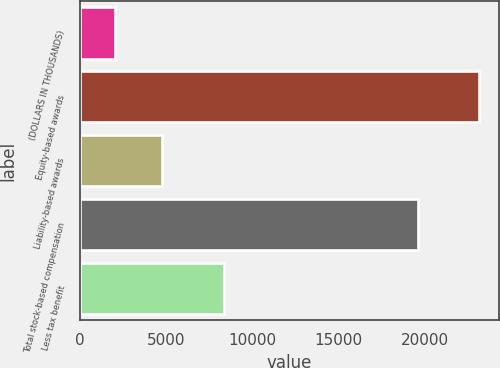Convert chart. <chart><loc_0><loc_0><loc_500><loc_500><bar_chart><fcel>(DOLLARS IN THOUSANDS)<fcel>Equity-based awards<fcel>Liability-based awards<fcel>Total stock-based compensation<fcel>Less tax benefit<nl><fcel>2015<fcel>23160<fcel>4784<fcel>19596<fcel>8348<nl></chart> 